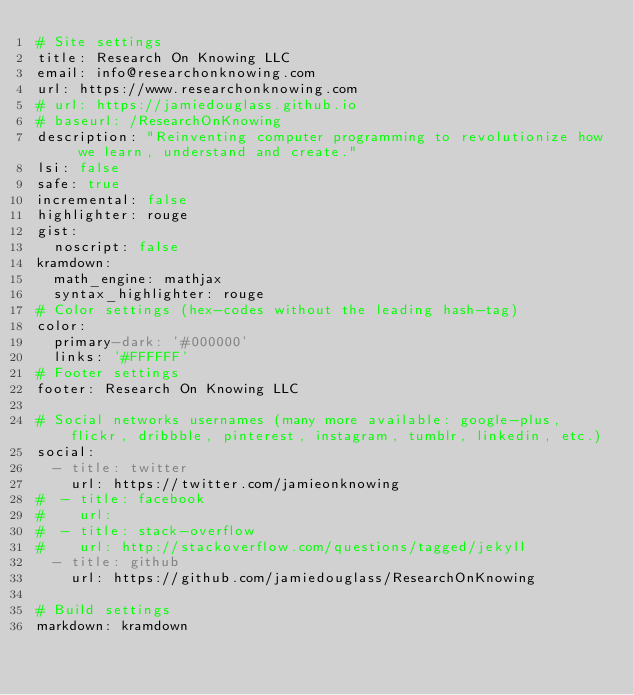Convert code to text. <code><loc_0><loc_0><loc_500><loc_500><_YAML_># Site settings
title: Research On Knowing LLC
email: info@researchonknowing.com
url: https://www.researchonknowing.com 
# url: https://jamiedouglass.github.io
# baseurl: /ResearchOnKnowing
description: "Reinventing computer programming to revolutionize how we learn, understand and create."
lsi: false
safe: true
incremental: false
highlighter: rouge
gist:
  noscript: false
kramdown:
  math_engine: mathjax
  syntax_highlighter: rouge
# Color settings (hex-codes without the leading hash-tag)
color:
  primary-dark: '#000000'
  links: '#FFFFFF'
# Footer settings
footer: Research On Knowing LLC

# Social networks usernames (many more available: google-plus, flickr, dribbble, pinterest, instagram, tumblr, linkedin, etc.)
social:
  - title: twitter
    url: https://twitter.com/jamieonknowing
#  - title: facebook
#    url:
#  - title: stack-overflow
#    url: http://stackoverflow.com/questions/tagged/jekyll
  - title: github
    url: https://github.com/jamiedouglass/ResearchOnKnowing

# Build settings
markdown: kramdown</code> 